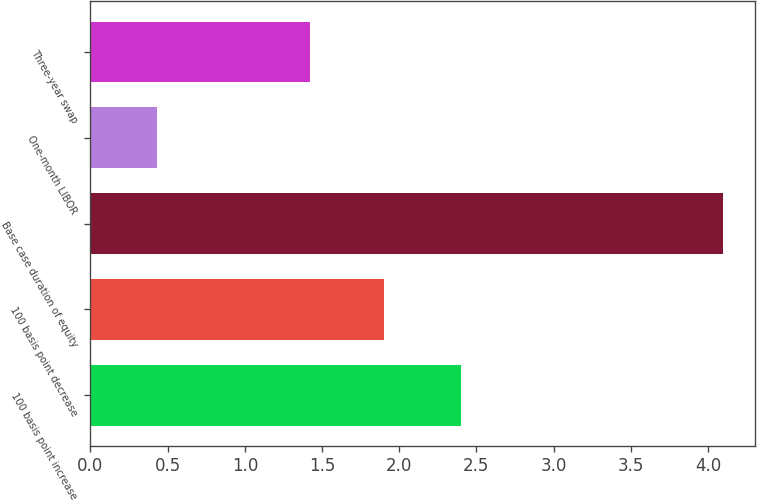<chart> <loc_0><loc_0><loc_500><loc_500><bar_chart><fcel>100 basis point increase<fcel>100 basis point decrease<fcel>Base case duration of equity<fcel>One-month LIBOR<fcel>Three-year swap<nl><fcel>2.4<fcel>1.9<fcel>4.1<fcel>0.43<fcel>1.42<nl></chart> 